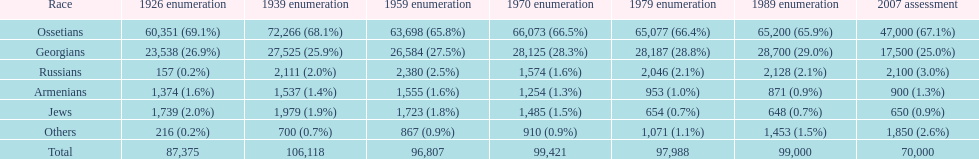Who is previous of the russians based on the list? Georgians. 